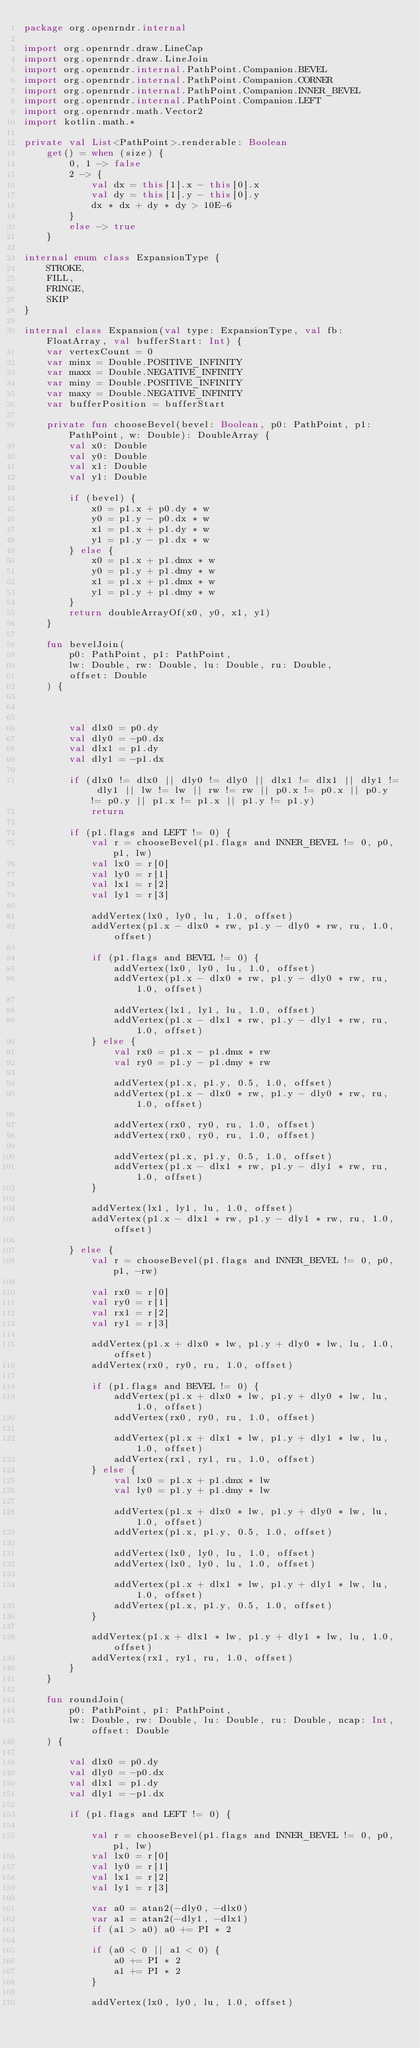<code> <loc_0><loc_0><loc_500><loc_500><_Kotlin_>package org.openrndr.internal

import org.openrndr.draw.LineCap
import org.openrndr.draw.LineJoin
import org.openrndr.internal.PathPoint.Companion.BEVEL
import org.openrndr.internal.PathPoint.Companion.CORNER
import org.openrndr.internal.PathPoint.Companion.INNER_BEVEL
import org.openrndr.internal.PathPoint.Companion.LEFT
import org.openrndr.math.Vector2
import kotlin.math.*

private val List<PathPoint>.renderable: Boolean
    get() = when (size) {
        0, 1 -> false
        2 -> {
            val dx = this[1].x - this[0].x
            val dy = this[1].y - this[0].y
            dx * dx + dy * dy > 10E-6
        }
        else -> true
    }

internal enum class ExpansionType {
    STROKE,
    FILL,
    FRINGE,
    SKIP
}

internal class Expansion(val type: ExpansionType, val fb: FloatArray, val bufferStart: Int) {
    var vertexCount = 0
    var minx = Double.POSITIVE_INFINITY
    var maxx = Double.NEGATIVE_INFINITY
    var miny = Double.POSITIVE_INFINITY
    var maxy = Double.NEGATIVE_INFINITY
    var bufferPosition = bufferStart

    private fun chooseBevel(bevel: Boolean, p0: PathPoint, p1: PathPoint, w: Double): DoubleArray {
        val x0: Double
        val y0: Double
        val x1: Double
        val y1: Double

        if (bevel) {
            x0 = p1.x + p0.dy * w
            y0 = p1.y - p0.dx * w
            x1 = p1.x + p1.dy * w
            y1 = p1.y - p1.dx * w
        } else {
            x0 = p1.x + p1.dmx * w
            y0 = p1.y + p1.dmy * w
            x1 = p1.x + p1.dmx * w
            y1 = p1.y + p1.dmy * w
        }
        return doubleArrayOf(x0, y0, x1, y1)
    }

    fun bevelJoin(
        p0: PathPoint, p1: PathPoint,
        lw: Double, rw: Double, lu: Double, ru: Double,
        offset: Double
    ) {



        val dlx0 = p0.dy
        val dly0 = -p0.dx
        val dlx1 = p1.dy
        val dly1 = -p1.dx

        if (dlx0 != dlx0 || dly0 != dly0 || dlx1 != dlx1 || dly1 != dly1 || lw != lw || rw != rw || p0.x != p0.x || p0.y != p0.y || p1.x != p1.x || p1.y != p1.y)
            return

        if (p1.flags and LEFT != 0) {
            val r = chooseBevel(p1.flags and INNER_BEVEL != 0, p0, p1, lw)
            val lx0 = r[0]
            val ly0 = r[1]
            val lx1 = r[2]
            val ly1 = r[3]

            addVertex(lx0, ly0, lu, 1.0, offset)
            addVertex(p1.x - dlx0 * rw, p1.y - dly0 * rw, ru, 1.0, offset)

            if (p1.flags and BEVEL != 0) {
                addVertex(lx0, ly0, lu, 1.0, offset)
                addVertex(p1.x - dlx0 * rw, p1.y - dly0 * rw, ru, 1.0, offset)

                addVertex(lx1, ly1, lu, 1.0, offset)
                addVertex(p1.x - dlx1 * rw, p1.y - dly1 * rw, ru, 1.0, offset)
            } else {
                val rx0 = p1.x - p1.dmx * rw
                val ry0 = p1.y - p1.dmy * rw

                addVertex(p1.x, p1.y, 0.5, 1.0, offset)
                addVertex(p1.x - dlx0 * rw, p1.y - dly0 * rw, ru, 1.0, offset)

                addVertex(rx0, ry0, ru, 1.0, offset)
                addVertex(rx0, ry0, ru, 1.0, offset)

                addVertex(p1.x, p1.y, 0.5, 1.0, offset)
                addVertex(p1.x - dlx1 * rw, p1.y - dly1 * rw, ru, 1.0, offset)
            }

            addVertex(lx1, ly1, lu, 1.0, offset)
            addVertex(p1.x - dlx1 * rw, p1.y - dly1 * rw, ru, 1.0, offset)

        } else {
            val r = chooseBevel(p1.flags and INNER_BEVEL != 0, p0, p1, -rw)

            val rx0 = r[0]
            val ry0 = r[1]
            val rx1 = r[2]
            val ry1 = r[3]

            addVertex(p1.x + dlx0 * lw, p1.y + dly0 * lw, lu, 1.0, offset)
            addVertex(rx0, ry0, ru, 1.0, offset)

            if (p1.flags and BEVEL != 0) {
                addVertex(p1.x + dlx0 * lw, p1.y + dly0 * lw, lu, 1.0, offset)
                addVertex(rx0, ry0, ru, 1.0, offset)

                addVertex(p1.x + dlx1 * lw, p1.y + dly1 * lw, lu, 1.0, offset)
                addVertex(rx1, ry1, ru, 1.0, offset)
            } else {
                val lx0 = p1.x + p1.dmx * lw
                val ly0 = p1.y + p1.dmy * lw

                addVertex(p1.x + dlx0 * lw, p1.y + dly0 * lw, lu, 1.0, offset)
                addVertex(p1.x, p1.y, 0.5, 1.0, offset)

                addVertex(lx0, ly0, lu, 1.0, offset)
                addVertex(lx0, ly0, lu, 1.0, offset)

                addVertex(p1.x + dlx1 * lw, p1.y + dly1 * lw, lu, 1.0, offset)
                addVertex(p1.x, p1.y, 0.5, 1.0, offset)
            }

            addVertex(p1.x + dlx1 * lw, p1.y + dly1 * lw, lu, 1.0, offset)
            addVertex(rx1, ry1, ru, 1.0, offset)
        }
    }

    fun roundJoin(
        p0: PathPoint, p1: PathPoint,
        lw: Double, rw: Double, lu: Double, ru: Double, ncap: Int, offset: Double
    ) {

        val dlx0 = p0.dy
        val dly0 = -p0.dx
        val dlx1 = p1.dy
        val dly1 = -p1.dx

        if (p1.flags and LEFT != 0) {

            val r = chooseBevel(p1.flags and INNER_BEVEL != 0, p0, p1, lw)
            val lx0 = r[0]
            val ly0 = r[1]
            val lx1 = r[2]
            val ly1 = r[3]

            var a0 = atan2(-dly0, -dlx0)
            var a1 = atan2(-dly1, -dlx1)
            if (a1 > a0) a0 += PI * 2

            if (a0 < 0 || a1 < 0) {
                a0 += PI * 2
                a1 += PI * 2
            }

            addVertex(lx0, ly0, lu, 1.0, offset)</code> 